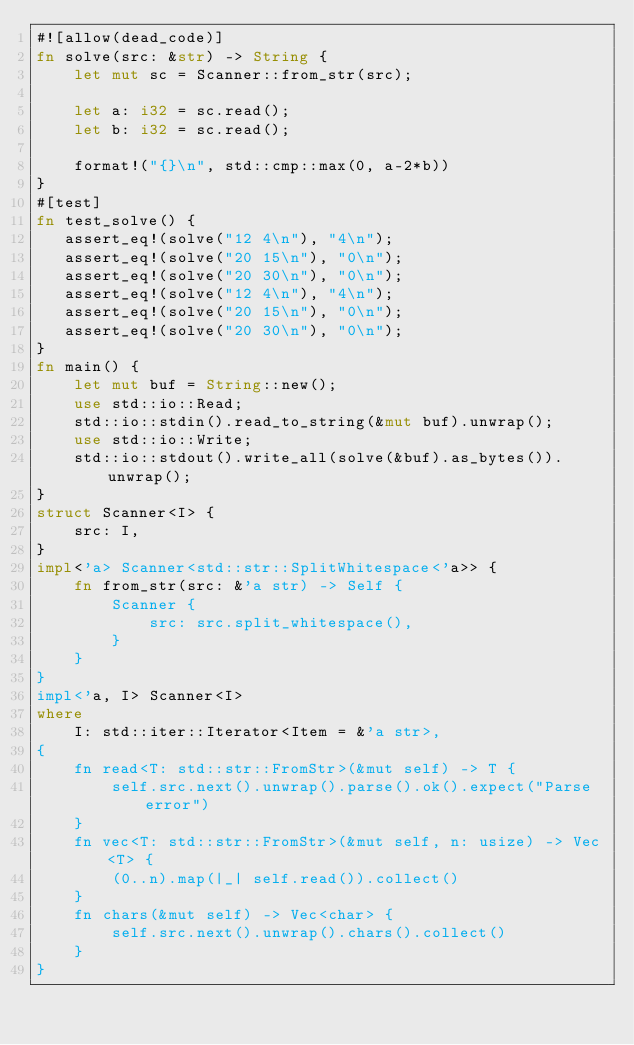Convert code to text. <code><loc_0><loc_0><loc_500><loc_500><_Rust_>#![allow(dead_code)]
fn solve(src: &str) -> String {
    let mut sc = Scanner::from_str(src);

    let a: i32 = sc.read();
    let b: i32 = sc.read();

    format!("{}\n", std::cmp::max(0, a-2*b))
}
#[test]
fn test_solve() {
   assert_eq!(solve("12 4\n"), "4\n");
   assert_eq!(solve("20 15\n"), "0\n");
   assert_eq!(solve("20 30\n"), "0\n");
   assert_eq!(solve("12 4\n"), "4\n");
   assert_eq!(solve("20 15\n"), "0\n");
   assert_eq!(solve("20 30\n"), "0\n");
}
fn main() {
    let mut buf = String::new();
    use std::io::Read;
    std::io::stdin().read_to_string(&mut buf).unwrap();
    use std::io::Write;
    std::io::stdout().write_all(solve(&buf).as_bytes()).unwrap();
}
struct Scanner<I> {
    src: I,
}
impl<'a> Scanner<std::str::SplitWhitespace<'a>> {
    fn from_str(src: &'a str) -> Self {
        Scanner {
            src: src.split_whitespace(),
        }
    }
}
impl<'a, I> Scanner<I>
where
    I: std::iter::Iterator<Item = &'a str>,
{
    fn read<T: std::str::FromStr>(&mut self) -> T {
        self.src.next().unwrap().parse().ok().expect("Parse error")
    }
    fn vec<T: std::str::FromStr>(&mut self, n: usize) -> Vec<T> {
        (0..n).map(|_| self.read()).collect()
    }
    fn chars(&mut self) -> Vec<char> {
        self.src.next().unwrap().chars().collect()
    }
}</code> 